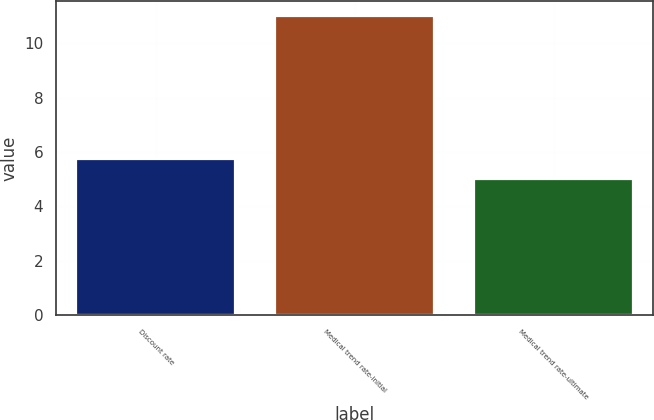Convert chart to OTSL. <chart><loc_0><loc_0><loc_500><loc_500><bar_chart><fcel>Discount rate<fcel>Medical trend rate-initial<fcel>Medical trend rate-ultimate<nl><fcel>5.75<fcel>11<fcel>5<nl></chart> 